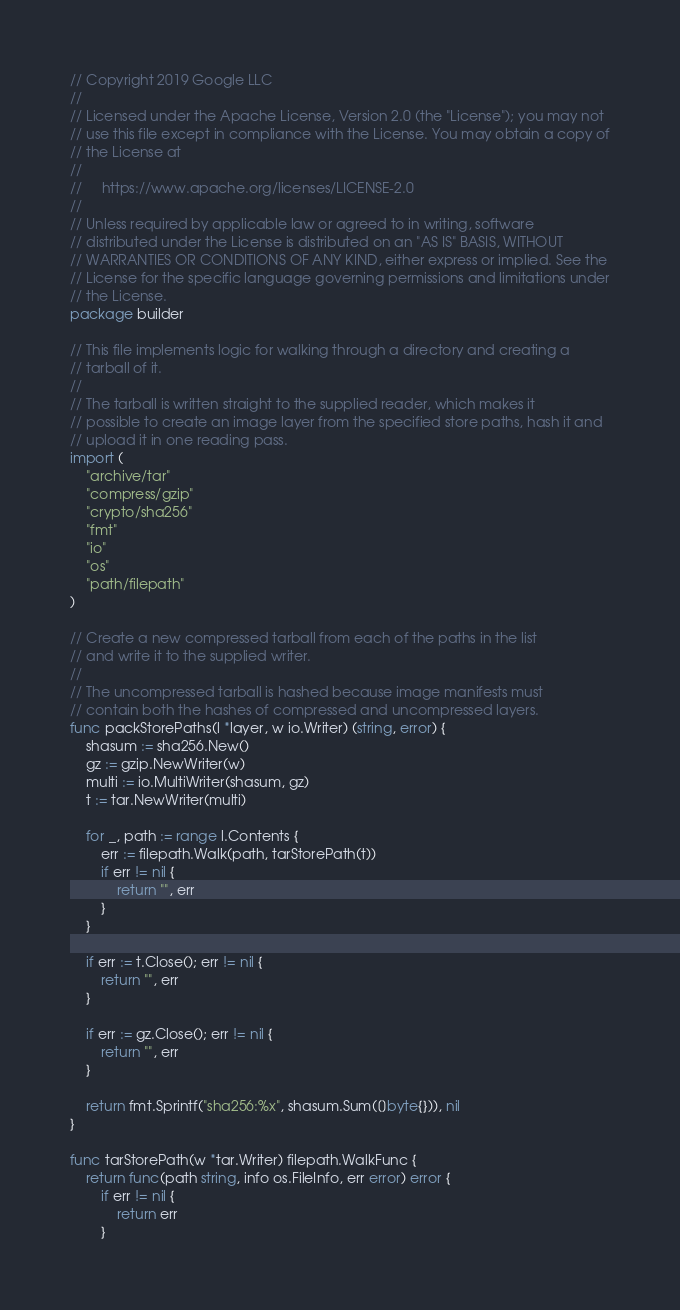<code> <loc_0><loc_0><loc_500><loc_500><_Go_>// Copyright 2019 Google LLC
//
// Licensed under the Apache License, Version 2.0 (the "License"); you may not
// use this file except in compliance with the License. You may obtain a copy of
// the License at
//
//     https://www.apache.org/licenses/LICENSE-2.0
//
// Unless required by applicable law or agreed to in writing, software
// distributed under the License is distributed on an "AS IS" BASIS, WITHOUT
// WARRANTIES OR CONDITIONS OF ANY KIND, either express or implied. See the
// License for the specific language governing permissions and limitations under
// the License.
package builder

// This file implements logic for walking through a directory and creating a
// tarball of it.
//
// The tarball is written straight to the supplied reader, which makes it
// possible to create an image layer from the specified store paths, hash it and
// upload it in one reading pass.
import (
	"archive/tar"
	"compress/gzip"
	"crypto/sha256"
	"fmt"
	"io"
	"os"
	"path/filepath"
)

// Create a new compressed tarball from each of the paths in the list
// and write it to the supplied writer.
//
// The uncompressed tarball is hashed because image manifests must
// contain both the hashes of compressed and uncompressed layers.
func packStorePaths(l *layer, w io.Writer) (string, error) {
	shasum := sha256.New()
	gz := gzip.NewWriter(w)
	multi := io.MultiWriter(shasum, gz)
	t := tar.NewWriter(multi)

	for _, path := range l.Contents {
		err := filepath.Walk(path, tarStorePath(t))
		if err != nil {
			return "", err
		}
	}

	if err := t.Close(); err != nil {
		return "", err
	}

	if err := gz.Close(); err != nil {
		return "", err
	}

	return fmt.Sprintf("sha256:%x", shasum.Sum([]byte{})), nil
}

func tarStorePath(w *tar.Writer) filepath.WalkFunc {
	return func(path string, info os.FileInfo, err error) error {
		if err != nil {
			return err
		}
</code> 